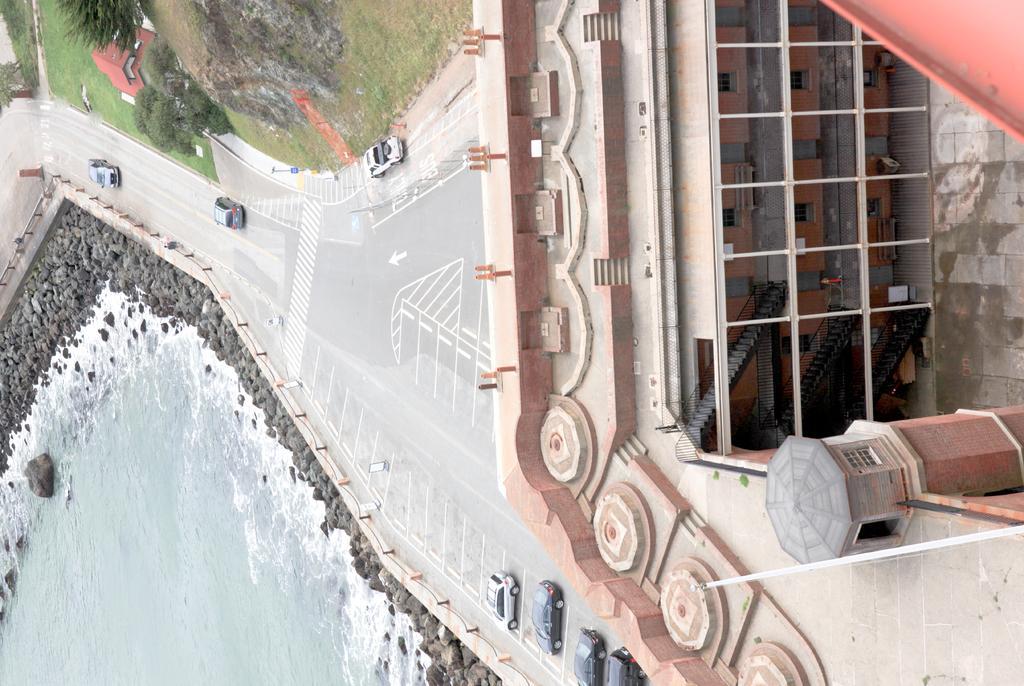Please provide a concise description of this image. In this image I can see a road in the centre and on it I can see number of vehicles. On the right side and on the top left side of this image I can see few buildings. I can also see few trees and grass on the top side and on the bottom left side I can see water and number of stones. 